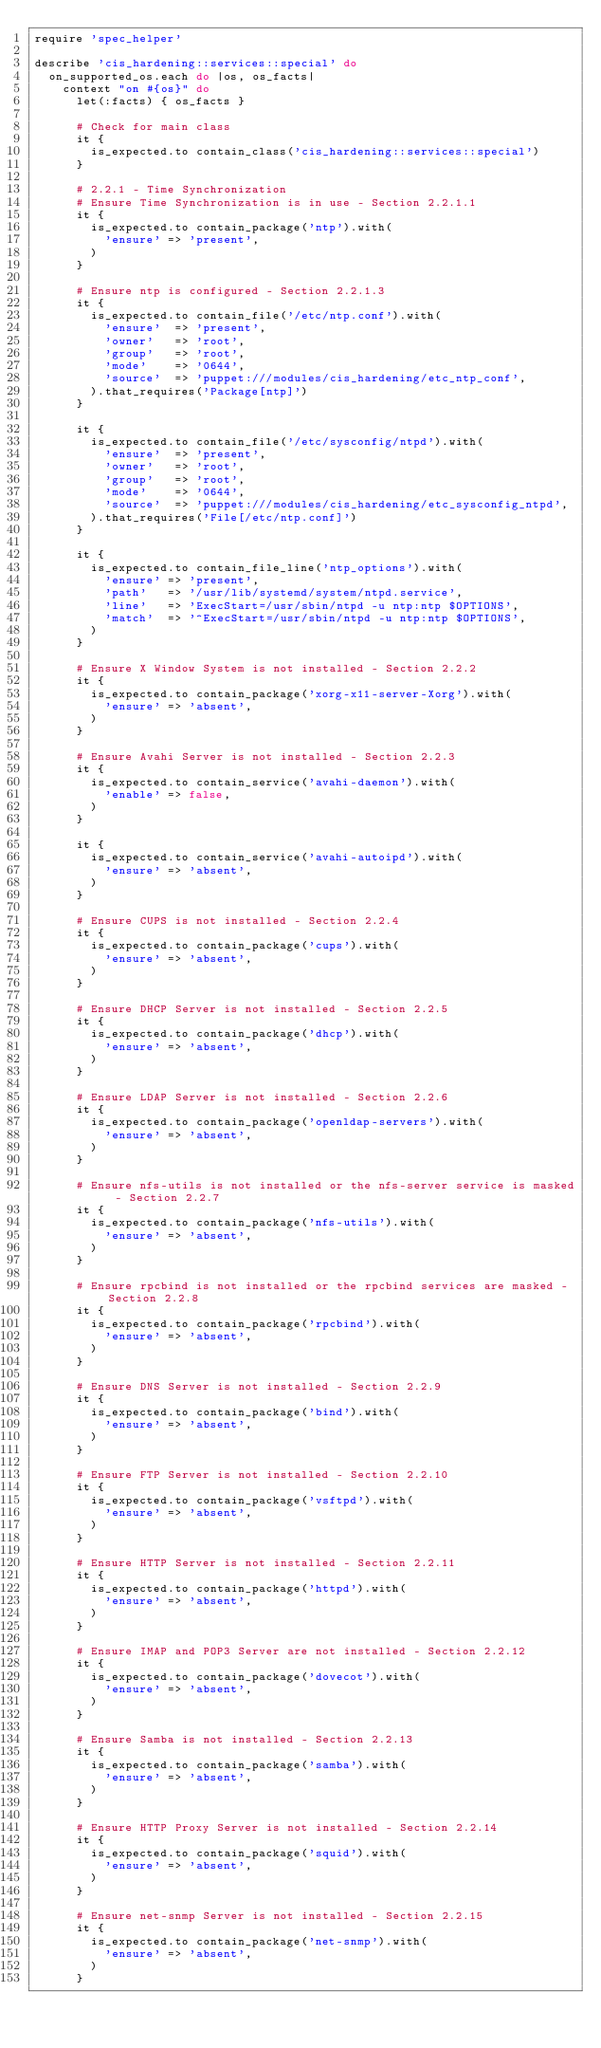<code> <loc_0><loc_0><loc_500><loc_500><_Ruby_>require 'spec_helper'

describe 'cis_hardening::services::special' do
  on_supported_os.each do |os, os_facts|
    context "on #{os}" do
      let(:facts) { os_facts }

      # Check for main class
      it {
        is_expected.to contain_class('cis_hardening::services::special')
      }

      # 2.2.1 - Time Synchronization
      # Ensure Time Synchronization is in use - Section 2.2.1.1
      it {
        is_expected.to contain_package('ntp').with(
          'ensure' => 'present',
        )
      }
      
      # Ensure ntp is configured - Section 2.2.1.3
      it {
        is_expected.to contain_file('/etc/ntp.conf').with(
          'ensure'  => 'present',
          'owner'   => 'root',
          'group'   => 'root',
          'mode'    => '0644',
          'source'  => 'puppet:///modules/cis_hardening/etc_ntp_conf',
        ).that_requires('Package[ntp]')
      }

      it {
        is_expected.to contain_file('/etc/sysconfig/ntpd').with(
          'ensure'  => 'present',
          'owner'   => 'root',
          'group'   => 'root',
          'mode'    => '0644',
          'source'  => 'puppet:///modules/cis_hardening/etc_sysconfig_ntpd',
        ).that_requires('File[/etc/ntp.conf]')
      }

      it {
        is_expected.to contain_file_line('ntp_options').with(
          'ensure' => 'present',
          'path'   => '/usr/lib/systemd/system/ntpd.service',
          'line'   => 'ExecStart=/usr/sbin/ntpd -u ntp:ntp $OPTIONS',
          'match'  => '^ExecStart=/usr/sbin/ntpd -u ntp:ntp $OPTIONS',
        )
      }
      
      # Ensure X Window System is not installed - Section 2.2.2
      it {
        is_expected.to contain_package('xorg-x11-server-Xorg').with(
          'ensure' => 'absent',
        )
      }

      # Ensure Avahi Server is not installed - Section 2.2.3
      it {
        is_expected.to contain_service('avahi-daemon').with(
          'enable' => false,
        )
      }

      it {
        is_expected.to contain_service('avahi-autoipd').with(
          'ensure' => 'absent',
        )
      }

      # Ensure CUPS is not installed - Section 2.2.4
      it {
        is_expected.to contain_package('cups').with(
          'ensure' => 'absent',
        )
      }

      # Ensure DHCP Server is not installed - Section 2.2.5
      it {
        is_expected.to contain_package('dhcp').with(
          'ensure' => 'absent',
        )
      }

      # Ensure LDAP Server is not installed - Section 2.2.6
      it {
        is_expected.to contain_package('openldap-servers').with(
          'ensure' => 'absent',
        )
      }

      # Ensure nfs-utils is not installed or the nfs-server service is masked - Section 2.2.7
      it {
        is_expected.to contain_package('nfs-utils').with(
          'ensure' => 'absent',
        )
      }

      # Ensure rpcbind is not installed or the rpcbind services are masked - Section 2.2.8
      it {
        is_expected.to contain_package('rpcbind').with(
          'ensure' => 'absent',
        )
      }

      # Ensure DNS Server is not installed - Section 2.2.9
      it {
        is_expected.to contain_package('bind').with(
          'ensure' => 'absent',
        )
      }

      # Ensure FTP Server is not installed - Section 2.2.10
      it {
        is_expected.to contain_package('vsftpd').with(
          'ensure' => 'absent',
        )
      }

      # Ensure HTTP Server is not installed - Section 2.2.11
      it {
        is_expected.to contain_package('httpd').with(
          'ensure' => 'absent',
        )
      }

      # Ensure IMAP and POP3 Server are not installed - Section 2.2.12
      it {
        is_expected.to contain_package('dovecot').with(
          'ensure' => 'absent',
        )
      }

      # Ensure Samba is not installed - Section 2.2.13
      it {
        is_expected.to contain_package('samba').with(
          'ensure' => 'absent',
        )
      }

      # Ensure HTTP Proxy Server is not installed - Section 2.2.14
      it {
        is_expected.to contain_package('squid').with(
          'ensure' => 'absent',
        )
      }

      # Ensure net-snmp Server is not installed - Section 2.2.15
      it {
        is_expected.to contain_package('net-snmp').with(
          'ensure' => 'absent',
        )
      }
</code> 